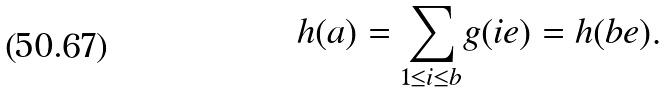<formula> <loc_0><loc_0><loc_500><loc_500>h ( a ) = \underset { 1 \leq i \leq b } \sum g ( i e ) = h ( b e ) .</formula> 